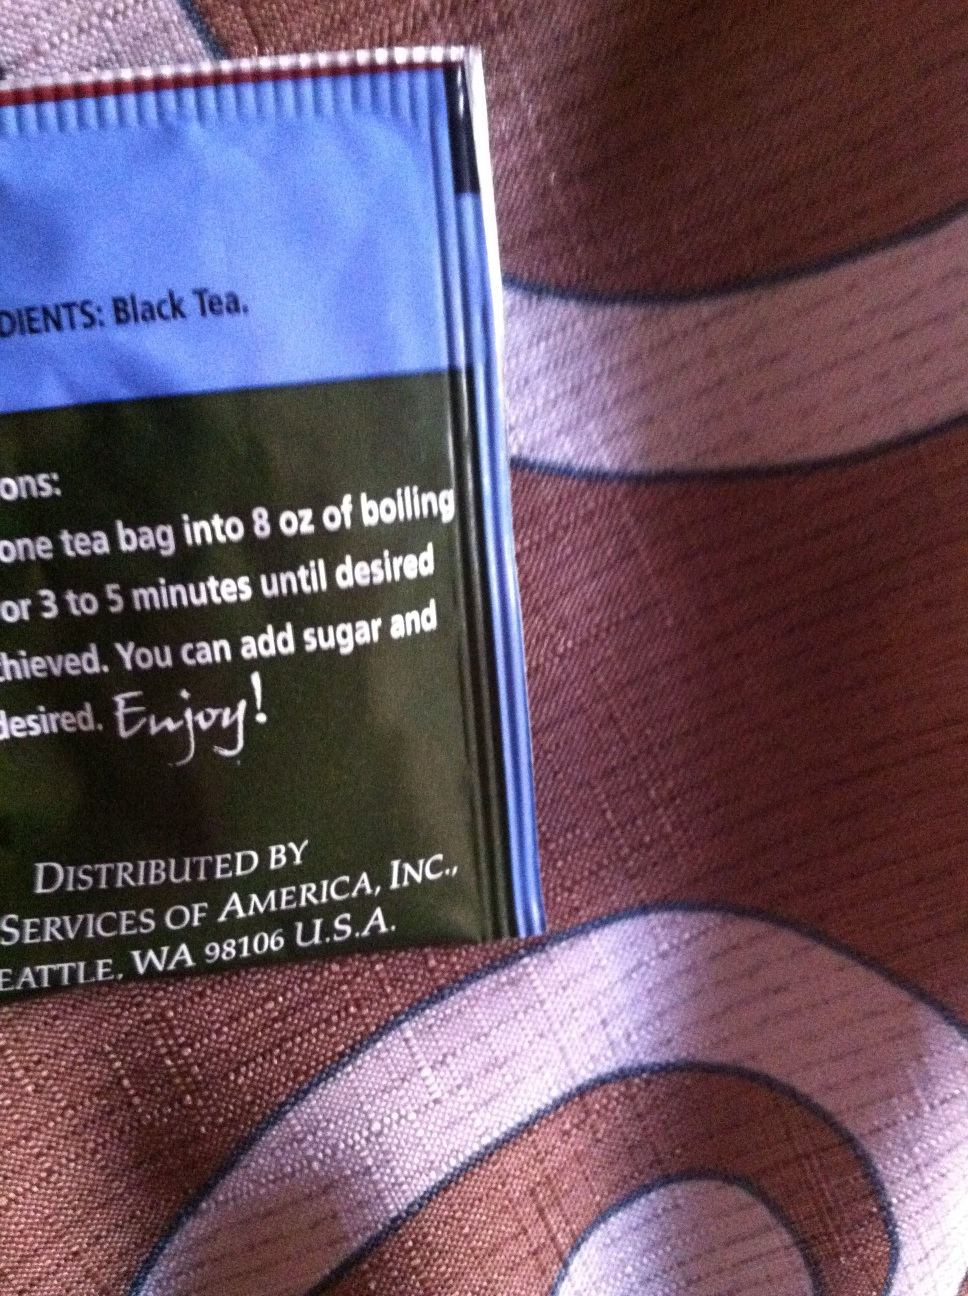Is black tea good for health? Yes, black tea is beneficial for health in several ways. It contains antioxidants that can help reduce the risk of chronic diseases and improve overall heart health. Drinking black tea may also aid in improving focus due to its caffeine content. 